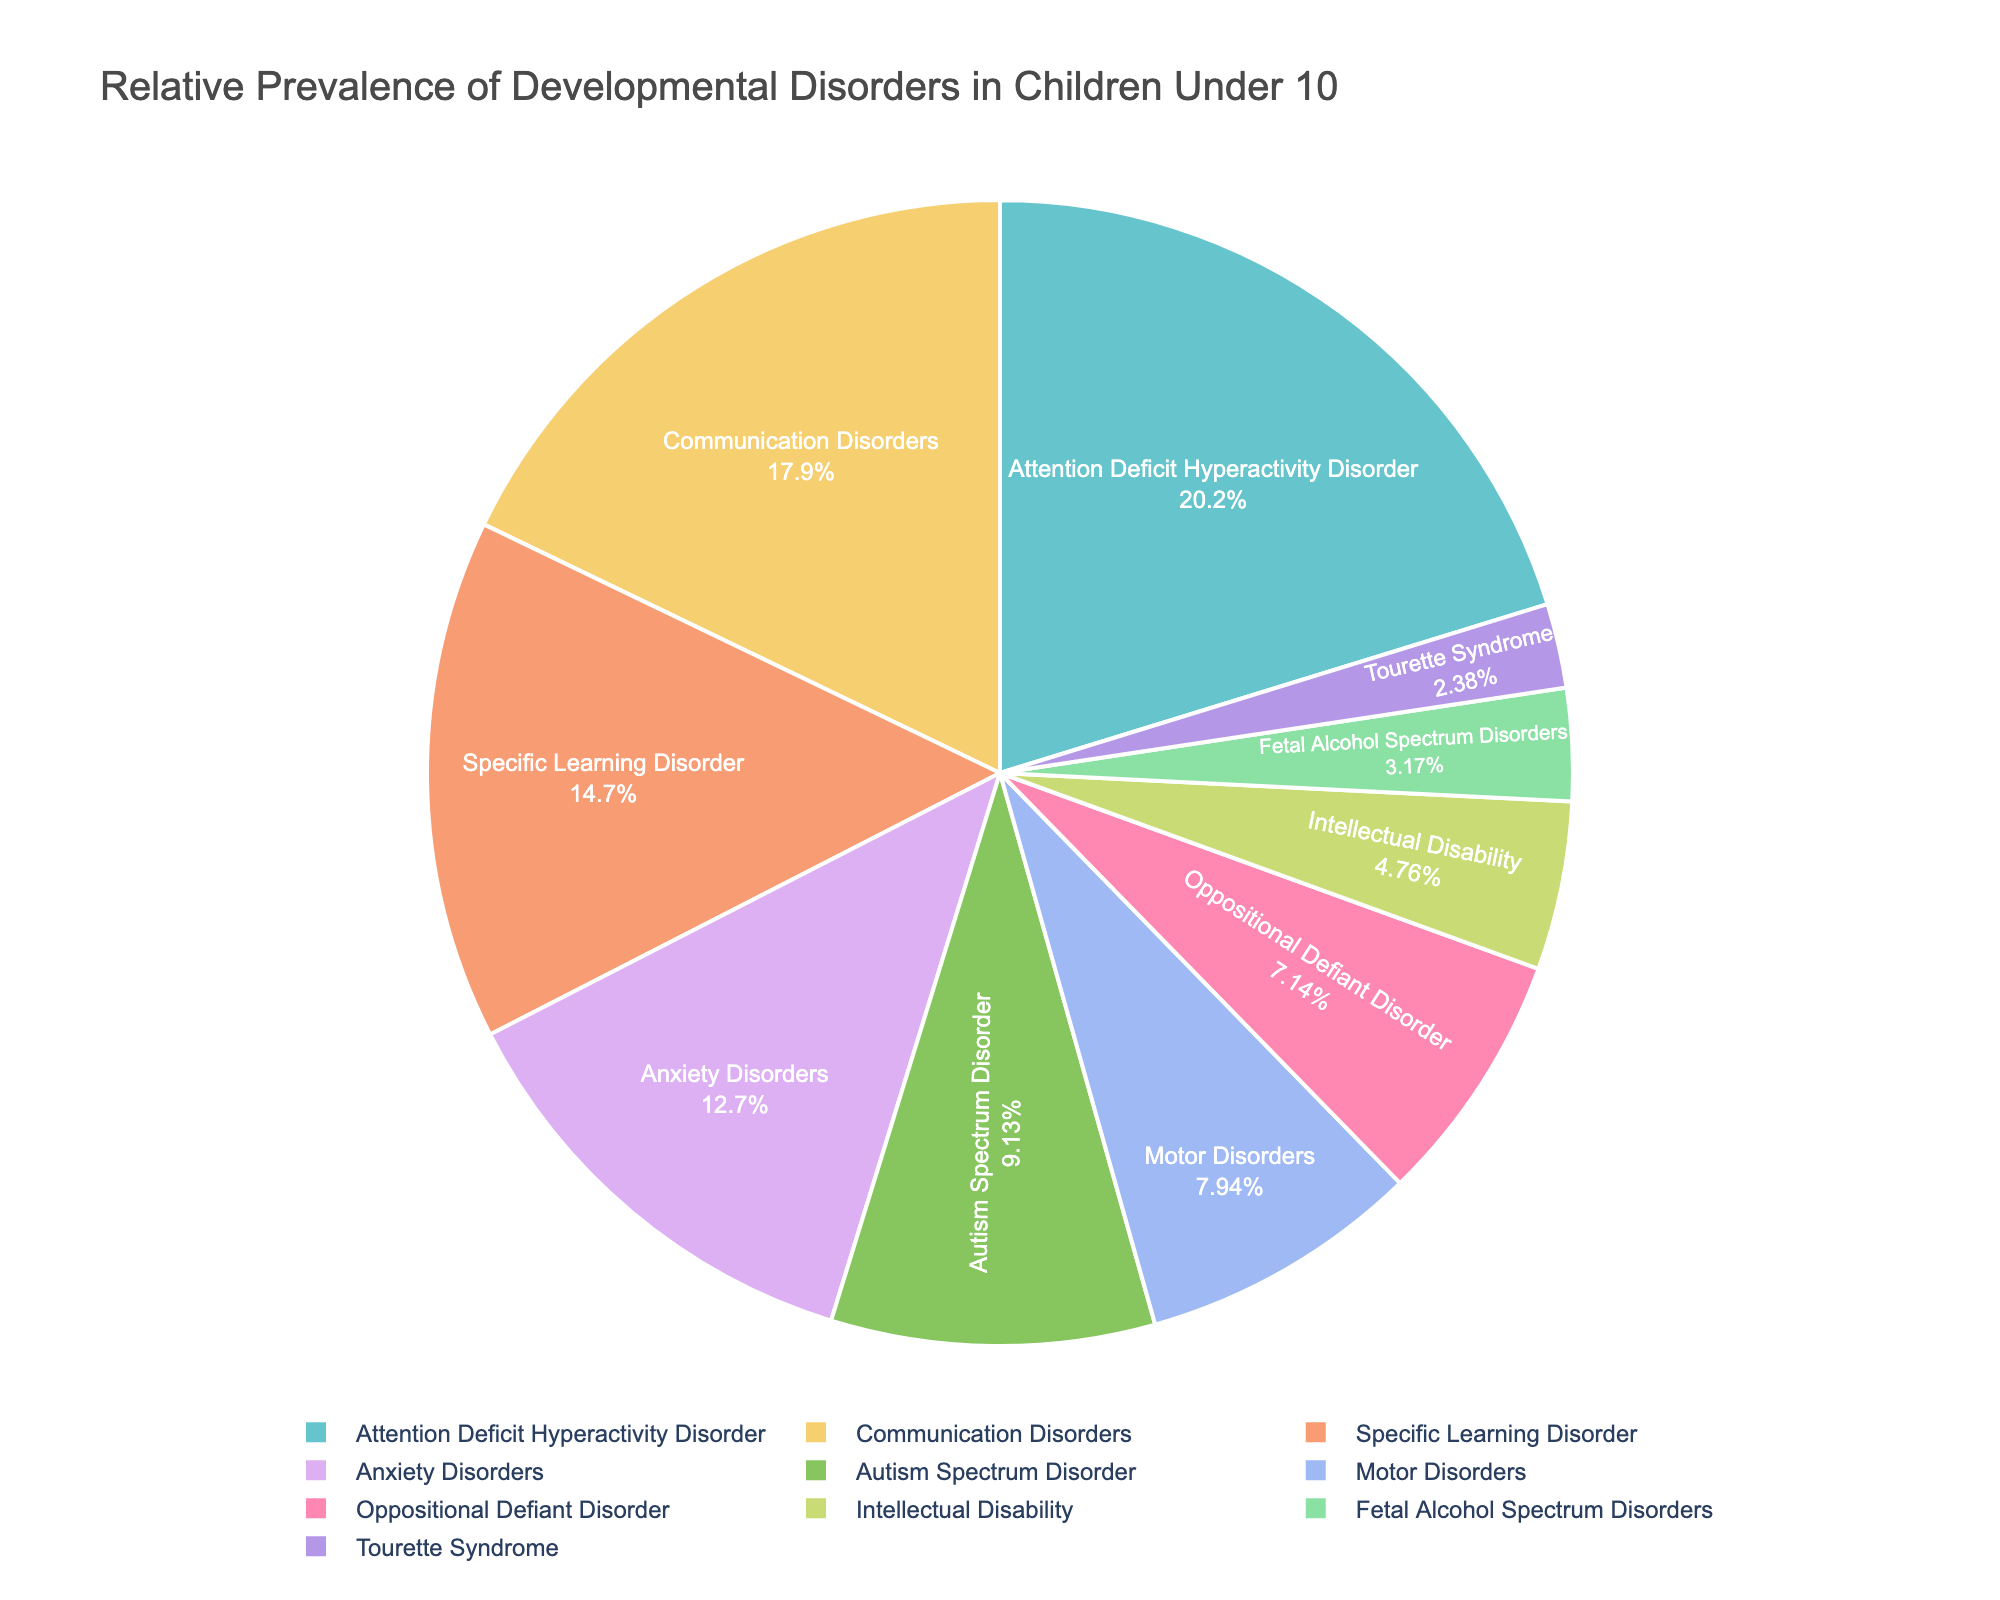What is the most prevalent developmental disorder in children under 10? The pie chart shows the relative prevalence of various developmental disorders, with Attention Deficit Hyperactivity Disorder (ADHD) having the largest section.
Answer: Attention Deficit Hyperactivity Disorder (ADHD) Which two disorders combined have a prevalence closest to that of Specific Learning Disorder? The prevalence of Specific Learning Disorder is 3.7%. Adding the disorders Anxiety Disorders (3.2%) and Tourette Syndrome (0.6%) gives a sum of 3.8%, which is closest to 3.7%.
Answer: Anxiety Disorders and Tourette Syndrome Is the prevalence of Autism Spectrum Disorder higher or lower than that of Motor Disorders? The pie chart shows Autism Spectrum Disorder at 2.3% and Motor Disorders at 2.0%. 2.3% is higher than 2.0%.
Answer: Higher What percentage of children under 10 have either Communication Disorders or Oppositional Defiant Disorder? Adding the prevalence rates: Communication Disorders (4.5%) + Oppositional Defiant Disorder (1.8%) = 6.3%.
Answer: 6.3% Which disorder has the smallest prevalence, and what is its value? The pie chart shows Tourette Syndrome with the smallest prevalence at 0.6%.
Answer: Tourette Syndrome, 0.6% Are there more children with Autism Spectrum Disorder or Fetal Alcohol Spectrum Disorders? Autism Spectrum Disorder has a prevalence of 2.3%, while Fetal Alcohol Spectrum Disorders have 0.8%. Since 2.3% is greater than 0.8%, there are more children with Autism Spectrum Disorder.
Answer: Autism Spectrum Disorder How does the prevalence of Communication Disorders compare to that of Specific Learning Disorder? From the pie chart, Communication Disorders are at 4.5%, and Specific Learning Disorder is at 3.7%. 4.5% is greater than 3.7%.
Answer: Higher Combined, what is the total prevalence of Attention Deficit Hyperactivity Disorder, Anxiety Disorders, and Motor Disorders? Adding the prevalence rates: ADHD (5.1%) + Anxiety Disorders (3.2%) + Motor Disorders (2.0%) = 10.3%.
Answer: 10.3% Is the prevalence of Intellectual Disability more than the combined prevalence of Tourette Syndrome and Fetal Alcohol Spectrum Disorders? Intellectual Disability is 1.2%. Tourette Syndrome is 0.6%, and Fetal Alcohol Spectrum Disorders is 0.8%. Their combined prevalence is 0.6% + 0.8% = 1.4%, which is greater than 1.2%.
Answer: No Which three disorders combined make up the highest overall prevalence? Adding the prevalence rates, the three highest combinations would be: ADHD (5.1%) + Communication Disorders (4.5%) + Specific Learning Disorder (3.7%) = 13.3%.
Answer: ADHD, Communication Disorders, Specific Learning Disorder 